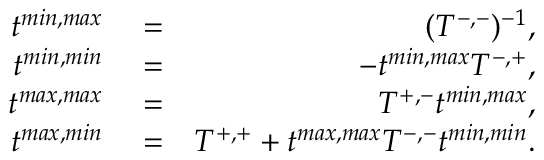<formula> <loc_0><loc_0><loc_500><loc_500>\begin{array} { r l r } { t ^ { \min , \max } } & = } & { ( T ^ { - , - } ) ^ { - 1 } , } \\ { t ^ { \min , \min } } & = } & { - t ^ { \min , \max } T ^ { - , + } , } \\ { t ^ { \max , \max } } & = } & { T ^ { + , - } t ^ { \min , \max } , } \\ { t ^ { \max , \min } } & = } & { T ^ { + , + } + t ^ { \max , \max } T ^ { - , - } t ^ { \min , \min } . } \end{array}</formula> 